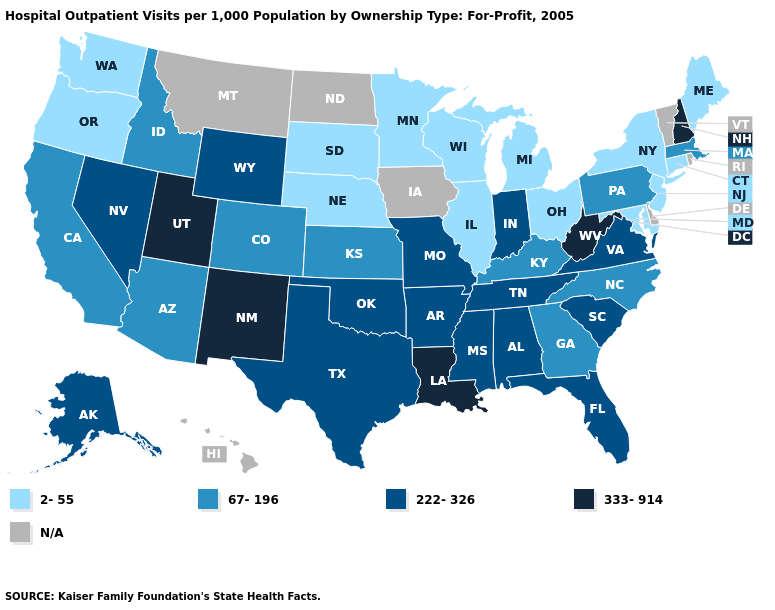What is the value of Nevada?
Keep it brief. 222-326. What is the value of Hawaii?
Give a very brief answer. N/A. What is the value of Tennessee?
Keep it brief. 222-326. Name the states that have a value in the range 67-196?
Keep it brief. Arizona, California, Colorado, Georgia, Idaho, Kansas, Kentucky, Massachusetts, North Carolina, Pennsylvania. Name the states that have a value in the range N/A?
Be succinct. Delaware, Hawaii, Iowa, Montana, North Dakota, Rhode Island, Vermont. What is the lowest value in states that border Maine?
Short answer required. 333-914. Does Washington have the highest value in the West?
Concise answer only. No. What is the lowest value in the Northeast?
Concise answer only. 2-55. Which states have the highest value in the USA?
Write a very short answer. Louisiana, New Hampshire, New Mexico, Utah, West Virginia. Name the states that have a value in the range 222-326?
Give a very brief answer. Alabama, Alaska, Arkansas, Florida, Indiana, Mississippi, Missouri, Nevada, Oklahoma, South Carolina, Tennessee, Texas, Virginia, Wyoming. Name the states that have a value in the range N/A?
Concise answer only. Delaware, Hawaii, Iowa, Montana, North Dakota, Rhode Island, Vermont. Name the states that have a value in the range N/A?
Short answer required. Delaware, Hawaii, Iowa, Montana, North Dakota, Rhode Island, Vermont. Among the states that border Kansas , which have the highest value?
Short answer required. Missouri, Oklahoma. What is the value of South Dakota?
Answer briefly. 2-55. 